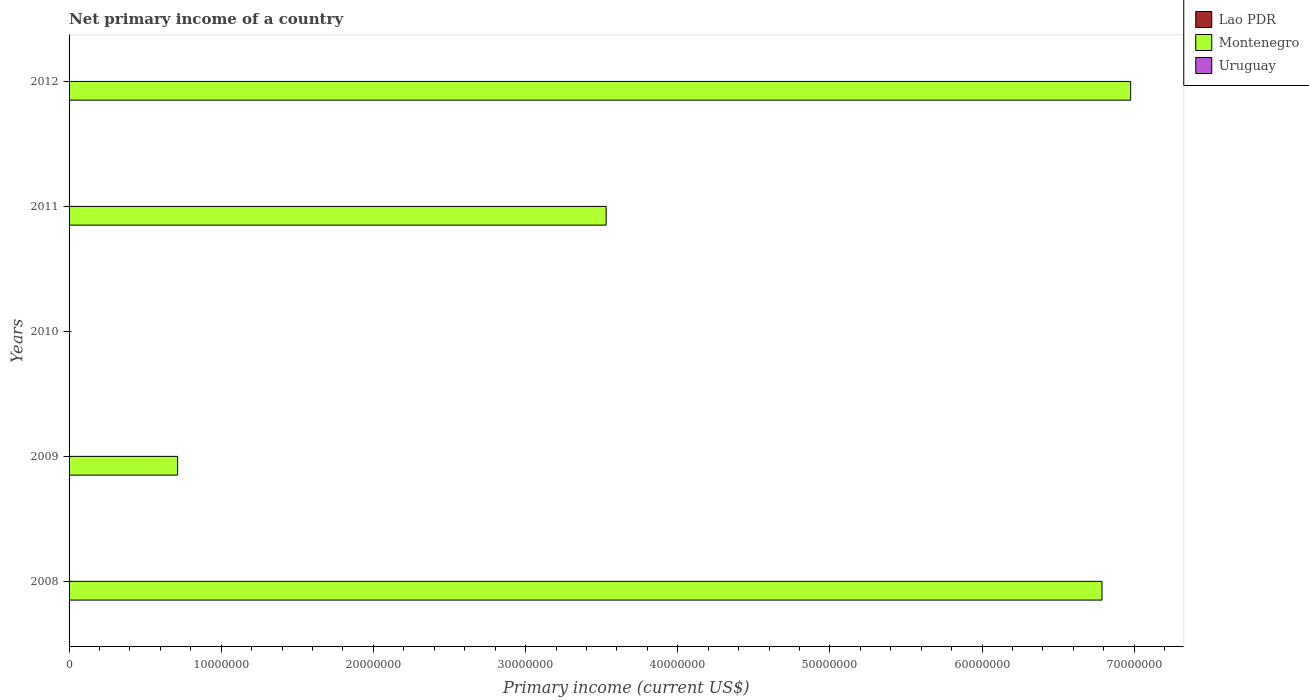How many different coloured bars are there?
Ensure brevity in your answer.  1. Are the number of bars per tick equal to the number of legend labels?
Provide a short and direct response. No. What is the primary income in Montenegro in 2011?
Provide a succinct answer. 3.53e+07. Across all years, what is the maximum primary income in Montenegro?
Your response must be concise. 6.98e+07. Across all years, what is the minimum primary income in Uruguay?
Your answer should be compact. 0. In which year was the primary income in Montenegro maximum?
Your answer should be very brief. 2012. What is the difference between the primary income in Montenegro in 2009 and that in 2012?
Give a very brief answer. -6.26e+07. What is the difference between the primary income in Montenegro in 2009 and the primary income in Uruguay in 2012?
Offer a very short reply. 7.13e+06. In how many years, is the primary income in Lao PDR greater than 58000000 US$?
Keep it short and to the point. 0. Is the primary income in Montenegro in 2009 less than that in 2012?
Provide a succinct answer. Yes. What is the difference between the highest and the second highest primary income in Montenegro?
Your answer should be very brief. 1.88e+06. What is the difference between the highest and the lowest primary income in Montenegro?
Provide a succinct answer. 6.98e+07. In how many years, is the primary income in Lao PDR greater than the average primary income in Lao PDR taken over all years?
Offer a terse response. 0. How many bars are there?
Make the answer very short. 4. What is the difference between two consecutive major ticks on the X-axis?
Your response must be concise. 1.00e+07. Are the values on the major ticks of X-axis written in scientific E-notation?
Your answer should be very brief. No. How are the legend labels stacked?
Provide a succinct answer. Vertical. What is the title of the graph?
Ensure brevity in your answer.  Net primary income of a country. Does "Ecuador" appear as one of the legend labels in the graph?
Keep it short and to the point. No. What is the label or title of the X-axis?
Provide a succinct answer. Primary income (current US$). What is the label or title of the Y-axis?
Keep it short and to the point. Years. What is the Primary income (current US$) in Lao PDR in 2008?
Offer a very short reply. 0. What is the Primary income (current US$) of Montenegro in 2008?
Your response must be concise. 6.79e+07. What is the Primary income (current US$) in Uruguay in 2008?
Your answer should be compact. 0. What is the Primary income (current US$) in Montenegro in 2009?
Give a very brief answer. 7.13e+06. What is the Primary income (current US$) of Uruguay in 2009?
Offer a terse response. 0. What is the Primary income (current US$) of Lao PDR in 2010?
Your answer should be very brief. 0. What is the Primary income (current US$) of Montenegro in 2010?
Give a very brief answer. 0. What is the Primary income (current US$) of Uruguay in 2010?
Offer a terse response. 0. What is the Primary income (current US$) in Montenegro in 2011?
Give a very brief answer. 3.53e+07. What is the Primary income (current US$) of Montenegro in 2012?
Provide a short and direct response. 6.98e+07. What is the Primary income (current US$) of Uruguay in 2012?
Provide a short and direct response. 0. Across all years, what is the maximum Primary income (current US$) of Montenegro?
Your response must be concise. 6.98e+07. Across all years, what is the minimum Primary income (current US$) in Montenegro?
Offer a terse response. 0. What is the total Primary income (current US$) of Lao PDR in the graph?
Provide a succinct answer. 0. What is the total Primary income (current US$) in Montenegro in the graph?
Your answer should be very brief. 1.80e+08. What is the total Primary income (current US$) in Uruguay in the graph?
Your response must be concise. 0. What is the difference between the Primary income (current US$) in Montenegro in 2008 and that in 2009?
Your response must be concise. 6.07e+07. What is the difference between the Primary income (current US$) in Montenegro in 2008 and that in 2011?
Provide a succinct answer. 3.26e+07. What is the difference between the Primary income (current US$) in Montenegro in 2008 and that in 2012?
Your answer should be compact. -1.88e+06. What is the difference between the Primary income (current US$) in Montenegro in 2009 and that in 2011?
Your answer should be very brief. -2.82e+07. What is the difference between the Primary income (current US$) in Montenegro in 2009 and that in 2012?
Make the answer very short. -6.26e+07. What is the difference between the Primary income (current US$) of Montenegro in 2011 and that in 2012?
Give a very brief answer. -3.45e+07. What is the average Primary income (current US$) of Montenegro per year?
Offer a terse response. 3.60e+07. What is the average Primary income (current US$) of Uruguay per year?
Give a very brief answer. 0. What is the ratio of the Primary income (current US$) of Montenegro in 2008 to that in 2009?
Give a very brief answer. 9.51. What is the ratio of the Primary income (current US$) in Montenegro in 2008 to that in 2011?
Your answer should be compact. 1.92. What is the ratio of the Primary income (current US$) in Montenegro in 2008 to that in 2012?
Provide a short and direct response. 0.97. What is the ratio of the Primary income (current US$) of Montenegro in 2009 to that in 2011?
Offer a terse response. 0.2. What is the ratio of the Primary income (current US$) of Montenegro in 2009 to that in 2012?
Make the answer very short. 0.1. What is the ratio of the Primary income (current US$) of Montenegro in 2011 to that in 2012?
Your response must be concise. 0.51. What is the difference between the highest and the second highest Primary income (current US$) of Montenegro?
Keep it short and to the point. 1.88e+06. What is the difference between the highest and the lowest Primary income (current US$) of Montenegro?
Offer a very short reply. 6.98e+07. 